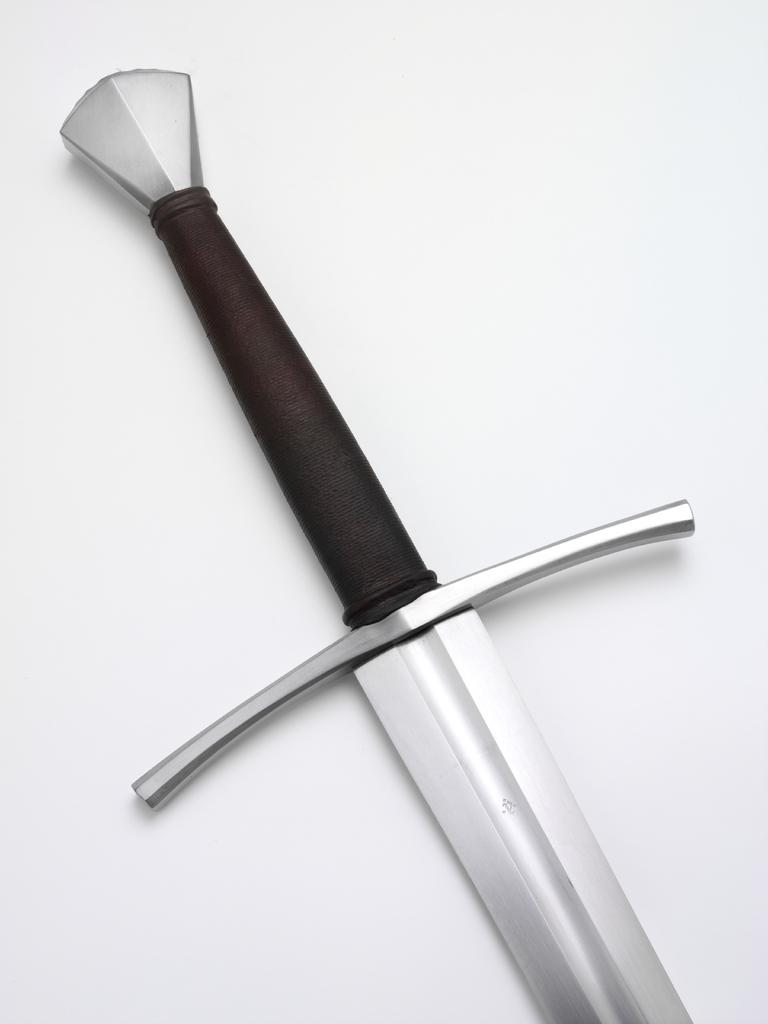What object is located in the middle of the image? There is a sword in the middle of the image. What type of protest is taking place in the image? There is no protest present in the image; it only features a sword in the middle. 